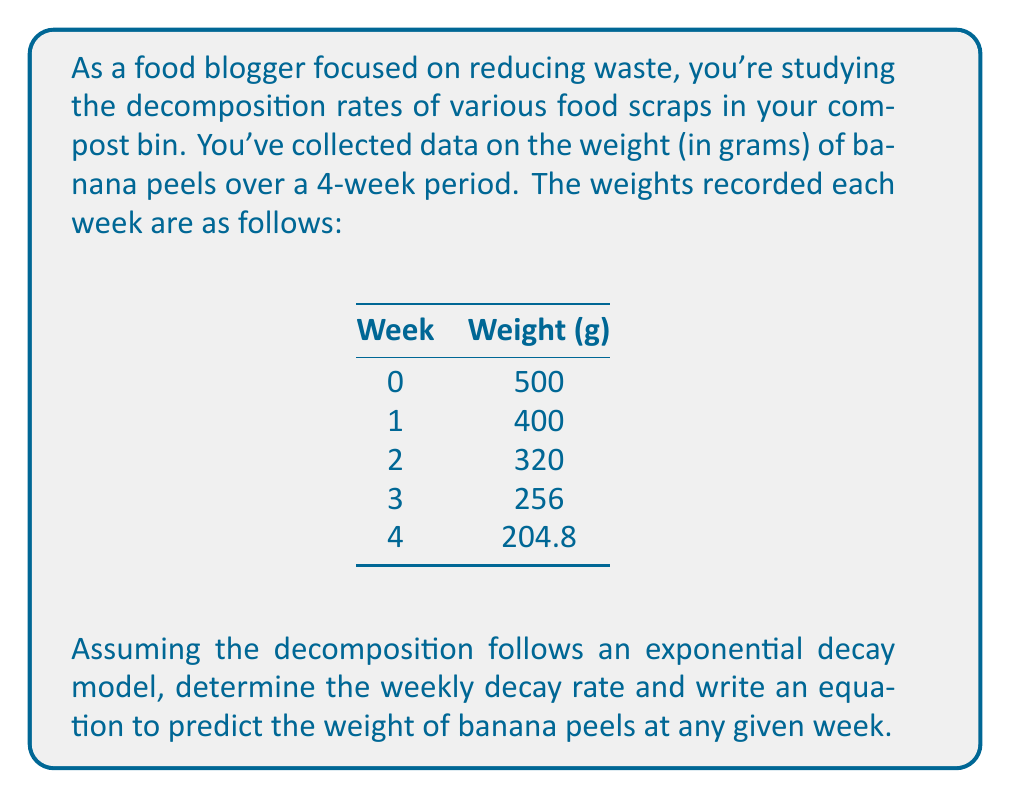Solve this math problem. To solve this problem, we'll follow these steps:

1) The general form of an exponential decay model is:

   $$W(t) = W_0 \cdot (1-r)^t$$

   Where:
   $W(t)$ is the weight at time $t$
   $W_0$ is the initial weight
   $r$ is the decay rate
   $t$ is the time (in weeks)

2) We can determine the decay rate by comparing any two consecutive measurements:

   $$\frac{W(t+1)}{W(t)} = 1-r$$

3) Let's use Week 0 and Week 1:

   $$\frac{400}{500} = 1-r$$
   $$0.8 = 1-r$$
   $$r = 1-0.8 = 0.2$$

4) We can verify this with other weeks:
   Week 1 to 2: $320/400 = 0.8$
   Week 2 to 3: $256/320 = 0.8$
   Week 3 to 4: $204.8/256 = 0.8$

5) Now we can write our equation:

   $$W(t) = 500 \cdot (1-0.2)^t = 500 \cdot (0.8)^t$$

6) To verify, let's calculate for Week 4:
   $$W(4) = 500 \cdot (0.8)^4 = 500 \cdot 0.4096 = 204.8g$$

   This matches our given data.
Answer: Weekly decay rate: 20%
Equation: $W(t) = 500 \cdot (0.8)^t$ 